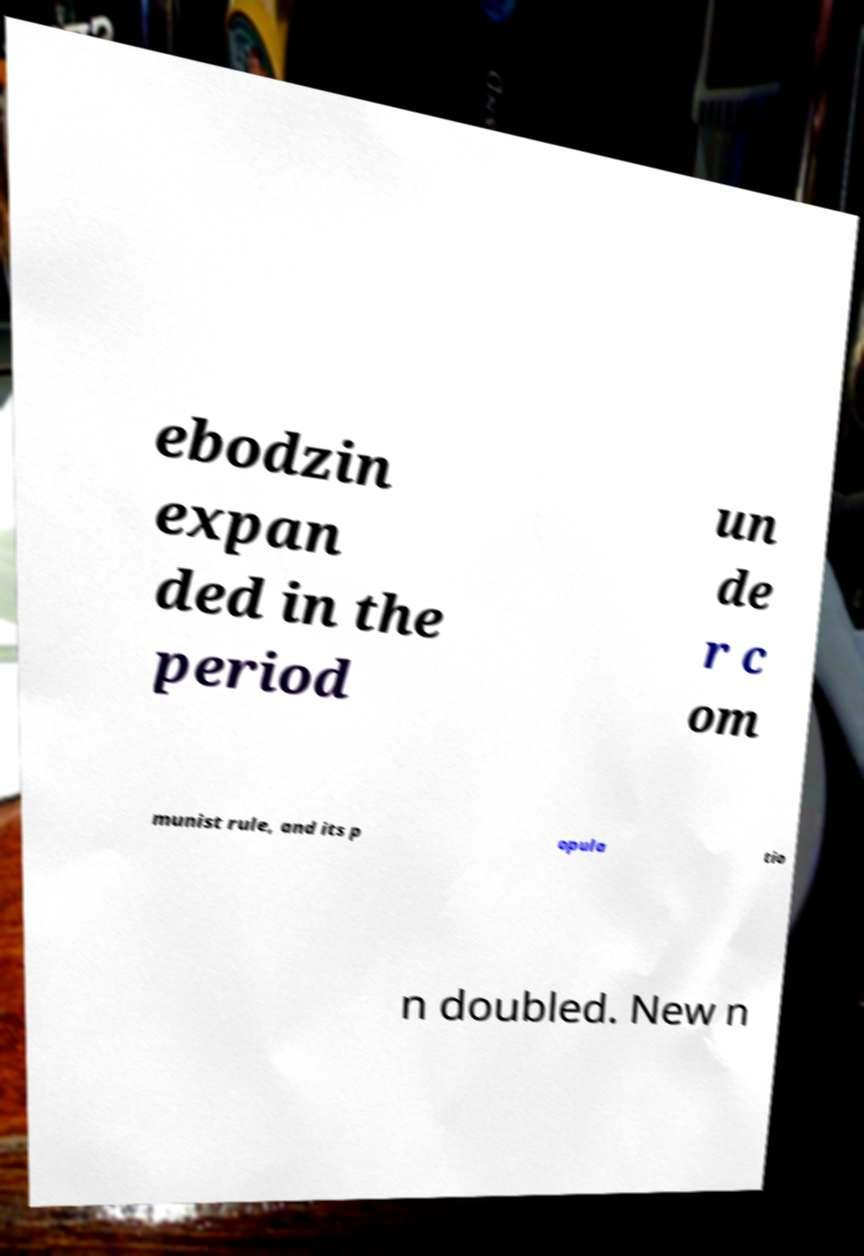There's text embedded in this image that I need extracted. Can you transcribe it verbatim? ebodzin expan ded in the period un de r c om munist rule, and its p opula tio n doubled. New n 